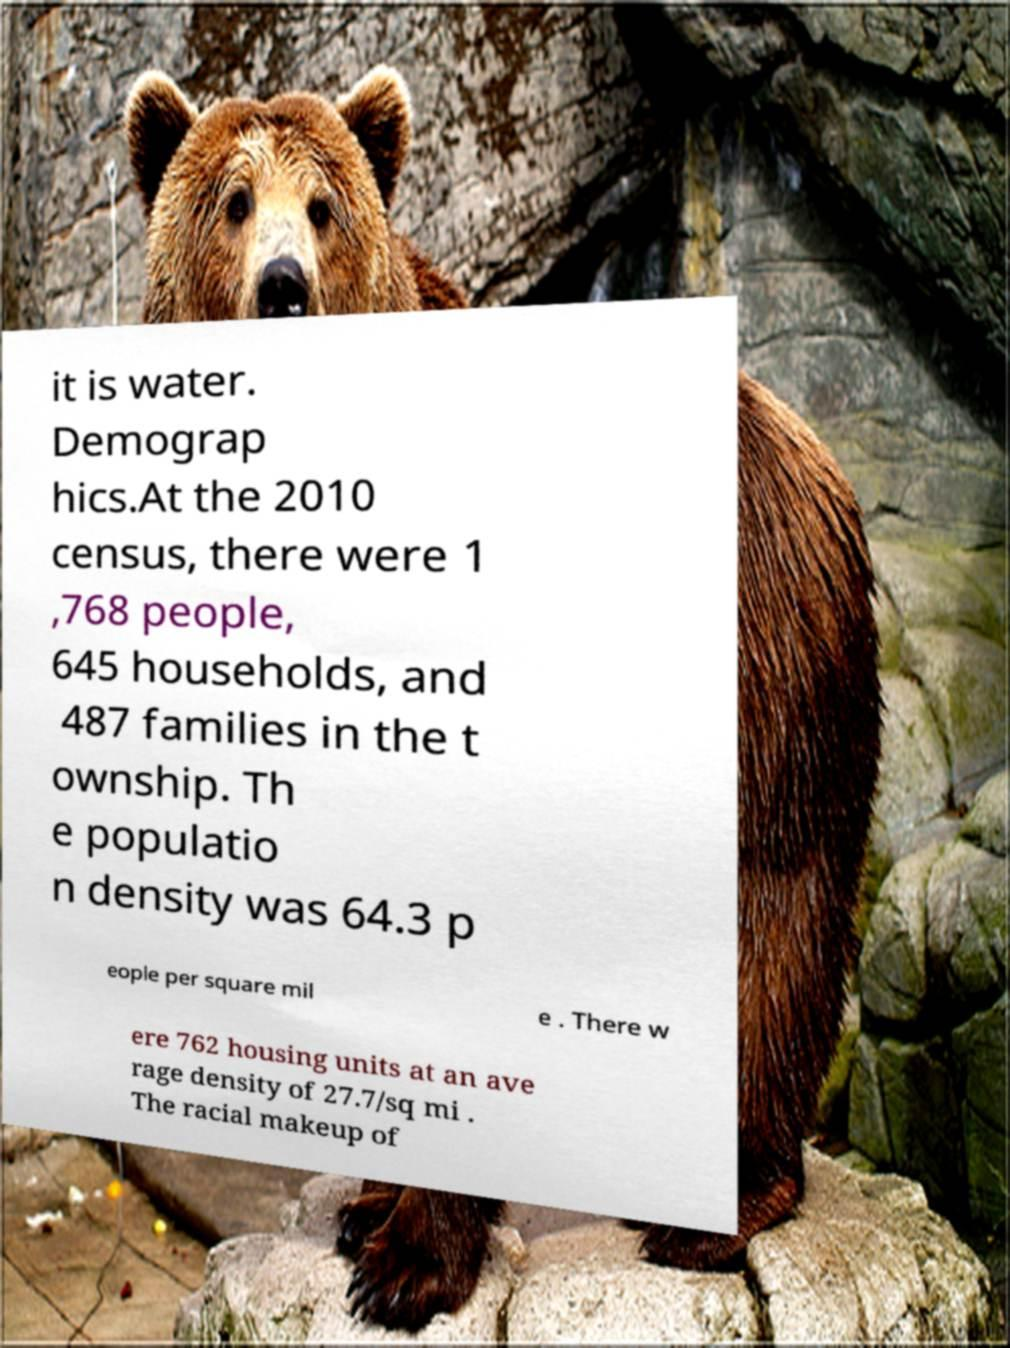I need the written content from this picture converted into text. Can you do that? it is water. Demograp hics.At the 2010 census, there were 1 ,768 people, 645 households, and 487 families in the t ownship. Th e populatio n density was 64.3 p eople per square mil e . There w ere 762 housing units at an ave rage density of 27.7/sq mi . The racial makeup of 